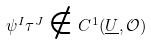Convert formula to latex. <formula><loc_0><loc_0><loc_500><loc_500>\psi ^ { I } \tau ^ { J } \notin C ^ { 1 } ( \underline { U } , \mathcal { O } )</formula> 